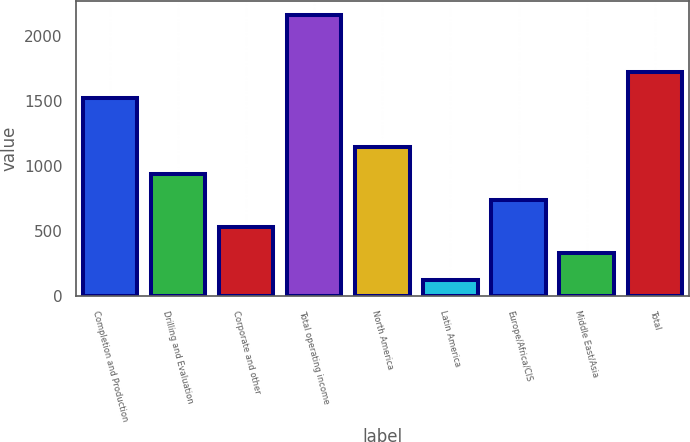<chart> <loc_0><loc_0><loc_500><loc_500><bar_chart><fcel>Completion and Production<fcel>Drilling and Evaluation<fcel>Corporate and other<fcel>Total operating income<fcel>North America<fcel>Latin America<fcel>Europe/Africa/CIS<fcel>Middle East/Asia<fcel>Total<nl><fcel>1524<fcel>941.2<fcel>533.6<fcel>2164<fcel>1145<fcel>126<fcel>737.4<fcel>329.8<fcel>1727.8<nl></chart> 